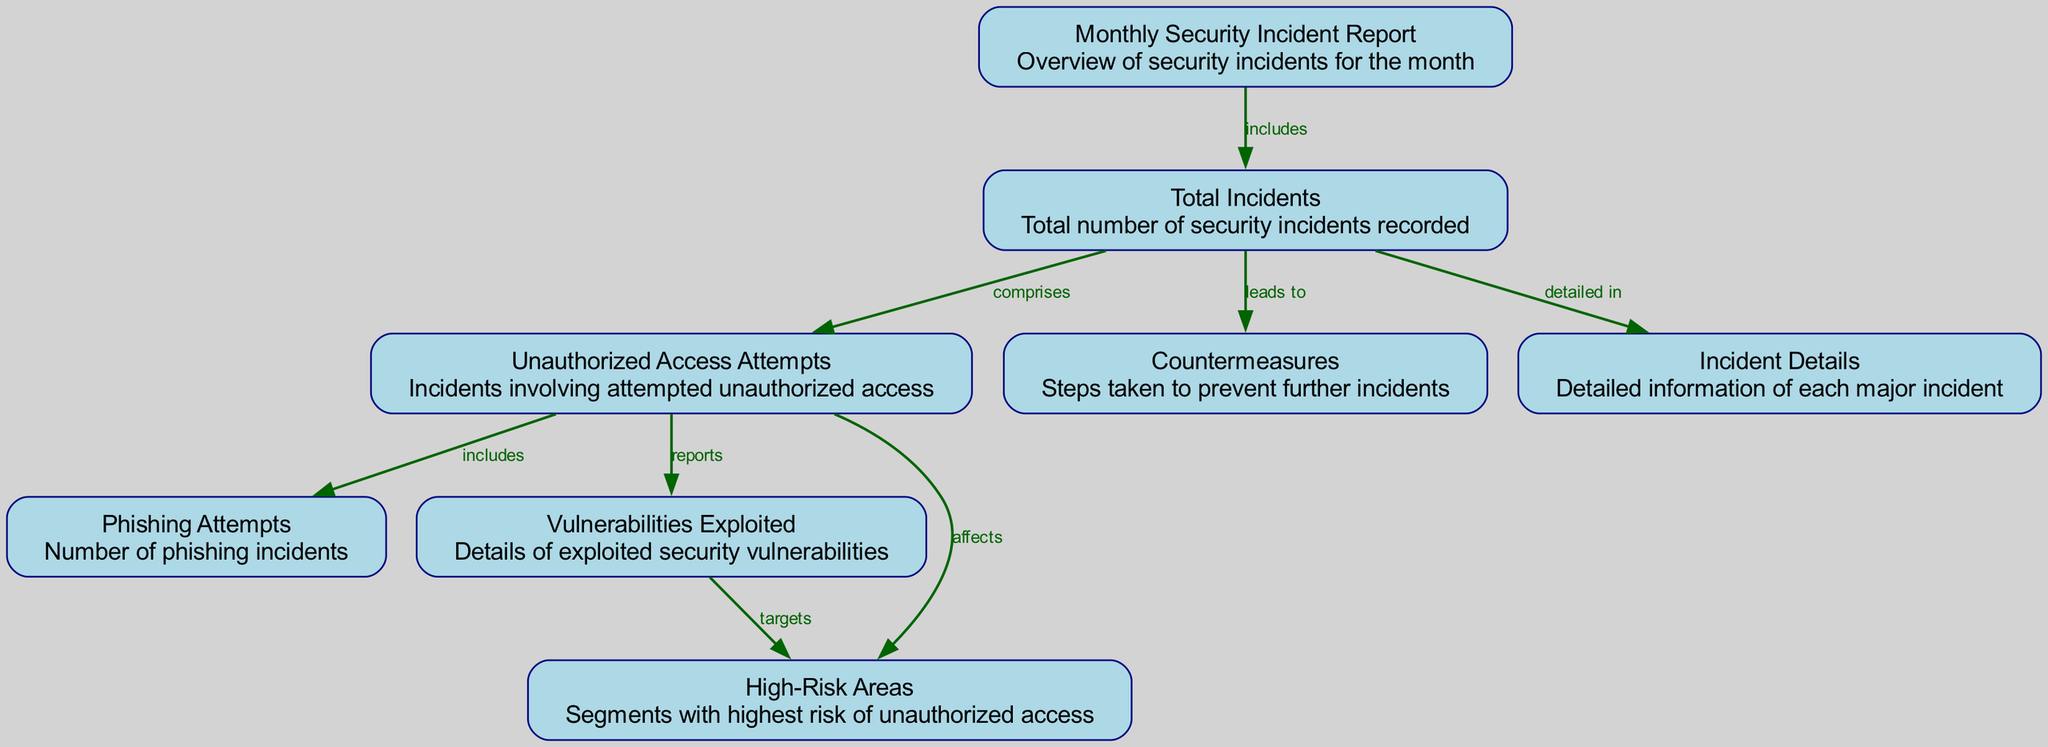What is the total number of security incidents recorded? The diagram includes a node labeled "Total Incidents," which directly presents the total number of security incidents. If this node is examined, the number of incidents is clearly indicated.
Answer: Total Incidents What does "Unauthorized Access Attempts" comprise? The "Unauthorized Access Attempts" node is connected to "Total Incidents" and is described as comprising incidents related to unauthorized access attempts. Therefore, it directly relates to the incidents categorized under that node.
Answer: Incidents How many categories of incidents are reported under "Unauthorized Access Attempts"? This can be determined by counting the edges originating from the "Unauthorized Access Attempts" node, which includes connections to the "Phishing Attempts" and "Vulnerabilities Exploited" nodes. There are three connections: one leads to Phishing Attempts, and another leads to Vulnerabilities Exploited.
Answer: 2 Which node targets "Vulnerabilities Exploited"? The edge outgoing from the "Vulnerabilities Exploited" node indicates which node targets it. Tracing back the edges, "High-Risk Areas" is the node that connects and indicates its targeting of vulnerabilities.
Answer: High-Risk Areas What leads to implementing "Countermeasures"? The diagram shows that "Total Incidents" leads to the node "Countermeasures." This means that the total count of incidents influences the actions taken to prevent further issues. By evaluating this connection, it is clear that the effectiveness of security measures is dependent on the total incidents recorded.
Answer: Total Incidents 